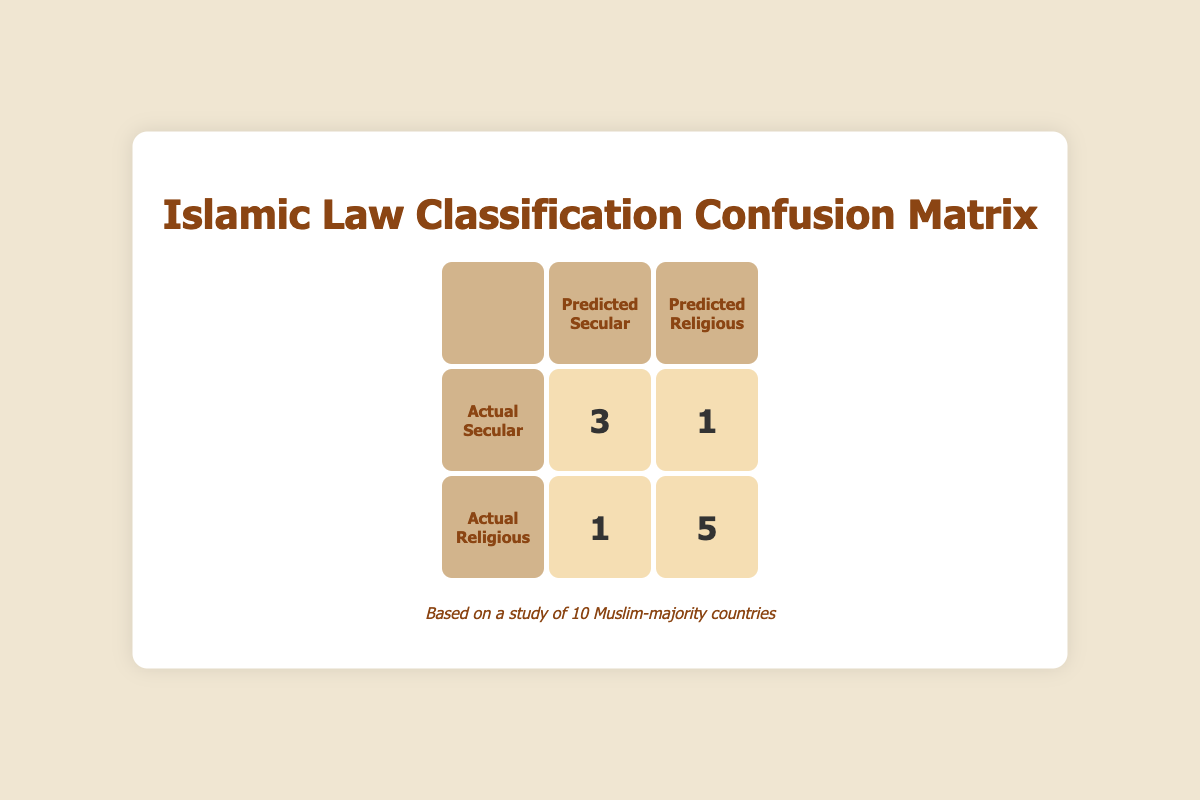What is the total number of countries classified as Secular? The table shows 3 countries that were predicted as Secular under 'Actual Secular' and 3 under 'Actual Religious', so the total is 3 + 3 = 6.
Answer: 6 How many countries did the model incorrectly classify as Secular? The model incorrectly classified 1 country (Egypt) which was actually Religious but predicted as Secular.
Answer: 1 What is the total number of countries that were correctly classified as Religious? The number of countries correctly predicted as Religious (True Negatives) is 5, as shown in the 'Actual Religious' row under 'Predicted Religious'.
Answer: 5 Did the model correctly predict more Secular or Religious countries? The model predicted 3 Secular correctly (True Positives) versus 5 Religious correctly (True Negatives), thus it predicted more Religious nations correctly.
Answer: Religious What is the difference between the number of True Positives and False Positives? The number of True Positives is 3 and the number of False Positives is 1; the difference is calculated as 3 - 1 = 2.
Answer: 2 How many countries were incorrectly predicted as Religious? The model incorrectly predicted 1 country (Indonesia) which was actually Secular but predicted as Religious.
Answer: 1 Are there any countries that were both actually Secular and predicted as Secular? Yes, Turkey, Bangladesh, and Tunisia were both actually Secular and predicted as Secular.
Answer: Yes What percentage of the countries were classified correctly? To find the percentage, we total the correctly classified countries (3 Secular + 5 Religious = 8) out of 10 countries, so (8/10) * 100 = 80%.
Answer: 80% What can be inferred about the model's prediction based on the confusion matrix? The model shows a tendency to favor predicting Religious countries accurately, indicating it may have a bias or a stronger relationship with the data from those nations.
Answer: Tendency to favor Religious predictions 